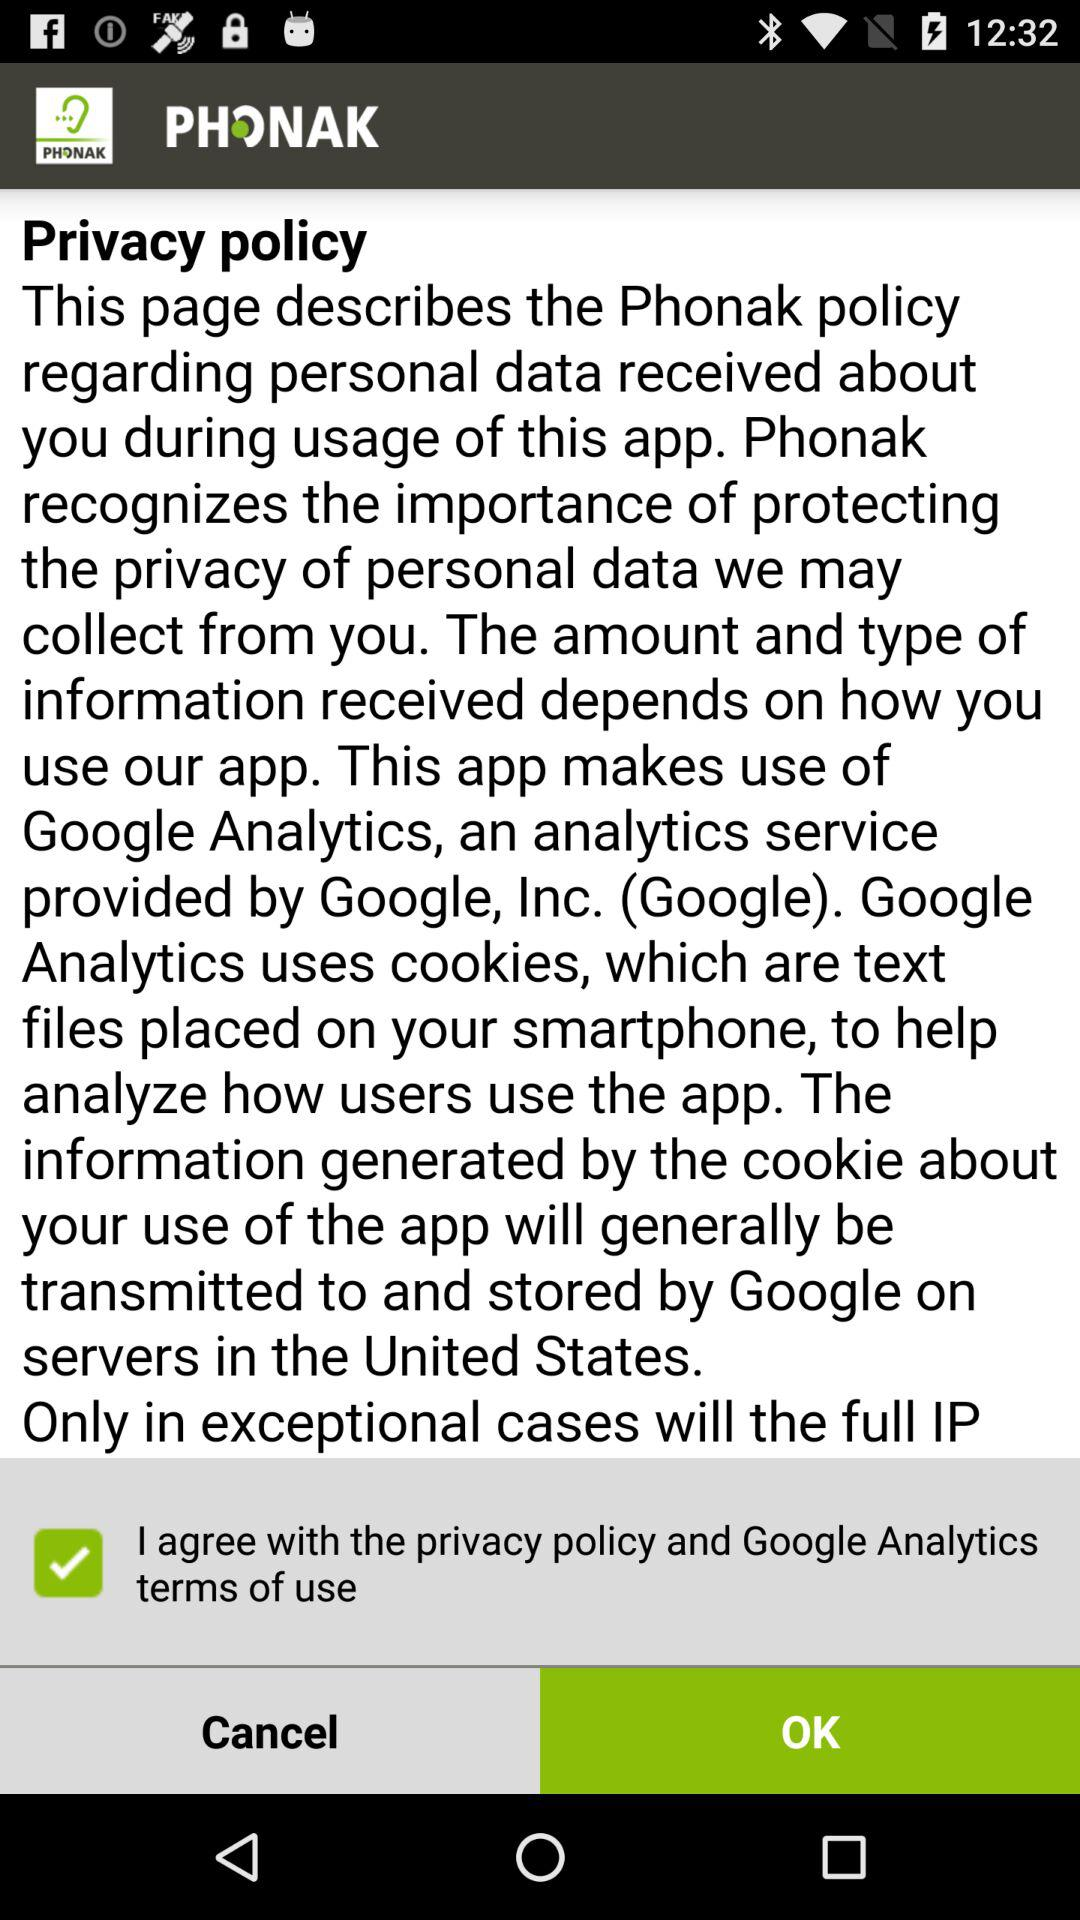What is the application name? The application name is "PHONAK". 